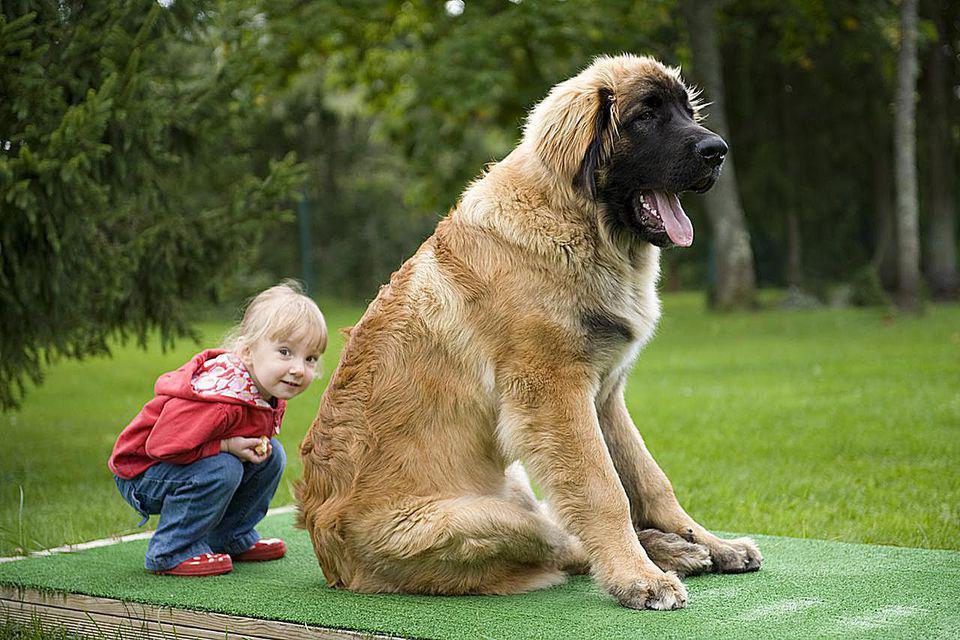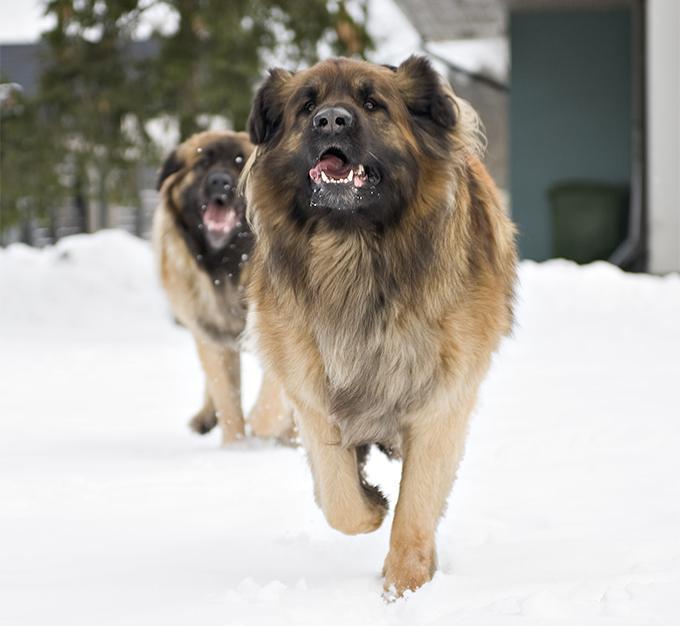The first image is the image on the left, the second image is the image on the right. Analyze the images presented: Is the assertion "An image shows at least one dog that is walking forward, with one front paw in front of the other." valid? Answer yes or no. Yes. The first image is the image on the left, the second image is the image on the right. Analyze the images presented: Is the assertion "There is at least one dog in the right image." valid? Answer yes or no. Yes. 